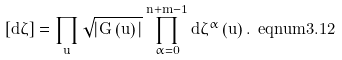<formula> <loc_0><loc_0><loc_500><loc_500>[ d \zeta ] = \prod _ { u } \sqrt { | G \left ( u \right ) | } \prod _ { \alpha = 0 } ^ { n + m - 1 } d \zeta ^ { \alpha } \left ( u \right ) . { \ e q n u m { 3 . 1 2 } }</formula> 